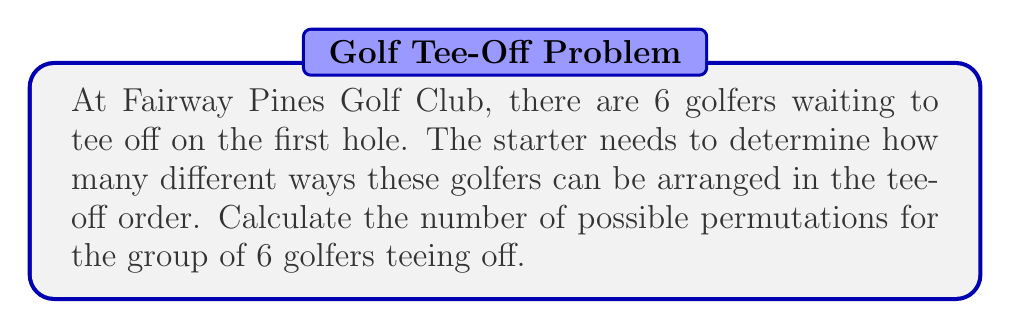Can you answer this question? To solve this problem, we need to use the concept of permutations from combinatorics, which is closely related to group theory in abstract algebra.

1. We have 6 distinct golfers, and we want to arrange all of them in a specific order.

2. This scenario is a perfect example of a permutation without repetition, where the order matters and each golfer can only be placed once.

3. The formula for permutations of n distinct objects is:

   $$P(n) = n!$$

   Where $n!$ represents the factorial of $n$.

4. In this case, $n = 6$, so we need to calculate $6!$

5. Let's expand this calculation:

   $$6! = 6 \times 5 \times 4 \times 3 \times 2 \times 1$$

6. Multiplying these numbers:

   $$6! = 720$$

Therefore, there are 720 different ways the starter can arrange the 6 golfers in the tee-off order.

This large number of possibilities is why golf courses often use pre-determined tee times to manage the flow of players more efficiently.
Answer: $720$ permutations 